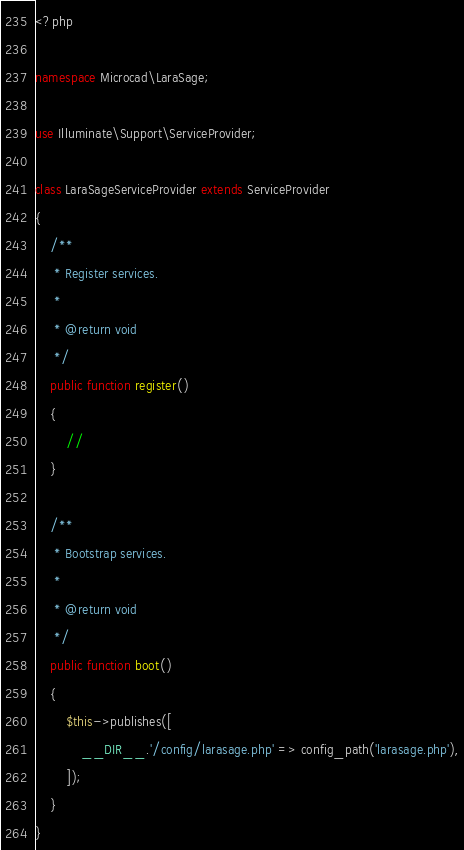Convert code to text. <code><loc_0><loc_0><loc_500><loc_500><_PHP_><?php

namespace Microcad\LaraSage;

use Illuminate\Support\ServiceProvider;

class LaraSageServiceProvider extends ServiceProvider
{
    /**
     * Register services.
     *
     * @return void
     */
    public function register()
    {
        //
    }

    /**
     * Bootstrap services.
     *
     * @return void
     */
    public function boot()
    {
        $this->publishes([
            __DIR__.'/config/larasage.php' => config_path('larasage.php'),
        ]);
    }
}
</code> 